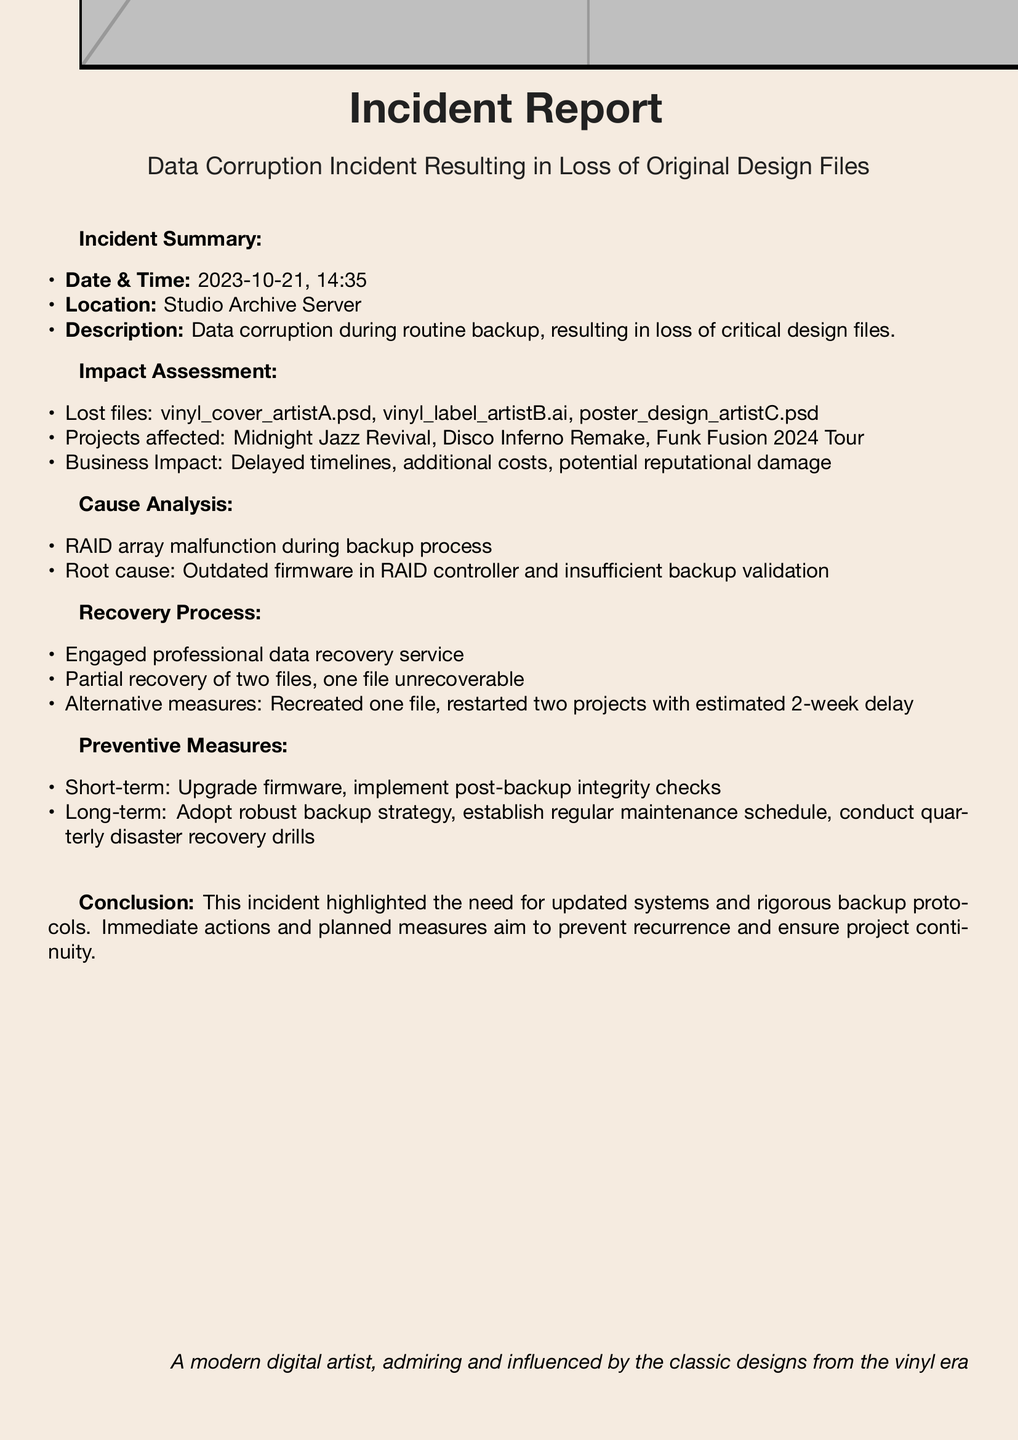what was the date of the incident? The incident date is mentioned in the document as "2023-10-21."
Answer: 2023-10-21 where did the incident occur? The location of the incident is specified in the document, indicating the affected area.
Answer: Studio Archive Server how many original design files were lost? The document lists three files as lost due to the incident.
Answer: three what was the root cause of the data corruption? The document states that the "outdated firmware in RAID controller" was identified as the root cause.
Answer: outdated firmware what actions were taken after the incident for recovery? The recovery process involved engaging a professional service, leading to partial recovery of files.
Answer: Engaged professional data recovery service what measure is suggested for long-term prevention? The report suggests adopting a "robust backup strategy" as a long-term preventive measure.
Answer: robust backup strategy which project was not recoverable? The document mentions that one of the files was unrecoverable during the recovery process.
Answer: one file unrecoverable how long is the estimated delay for restarting projects? The estimated delay for restarting the affected projects is stated in the document as two weeks.
Answer: 2-week delay what type of drill is suggested for disaster recovery? The document recommends conducting "quarterly disaster recovery drills" as part of the preventive measures.
Answer: quarterly disaster recovery drills 